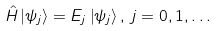<formula> <loc_0><loc_0><loc_500><loc_500>\hat { H } \left | \psi _ { j } \right \rangle = E _ { j } \left | \psi _ { j } \right \rangle , \, j = 0 , 1 , \dots</formula> 